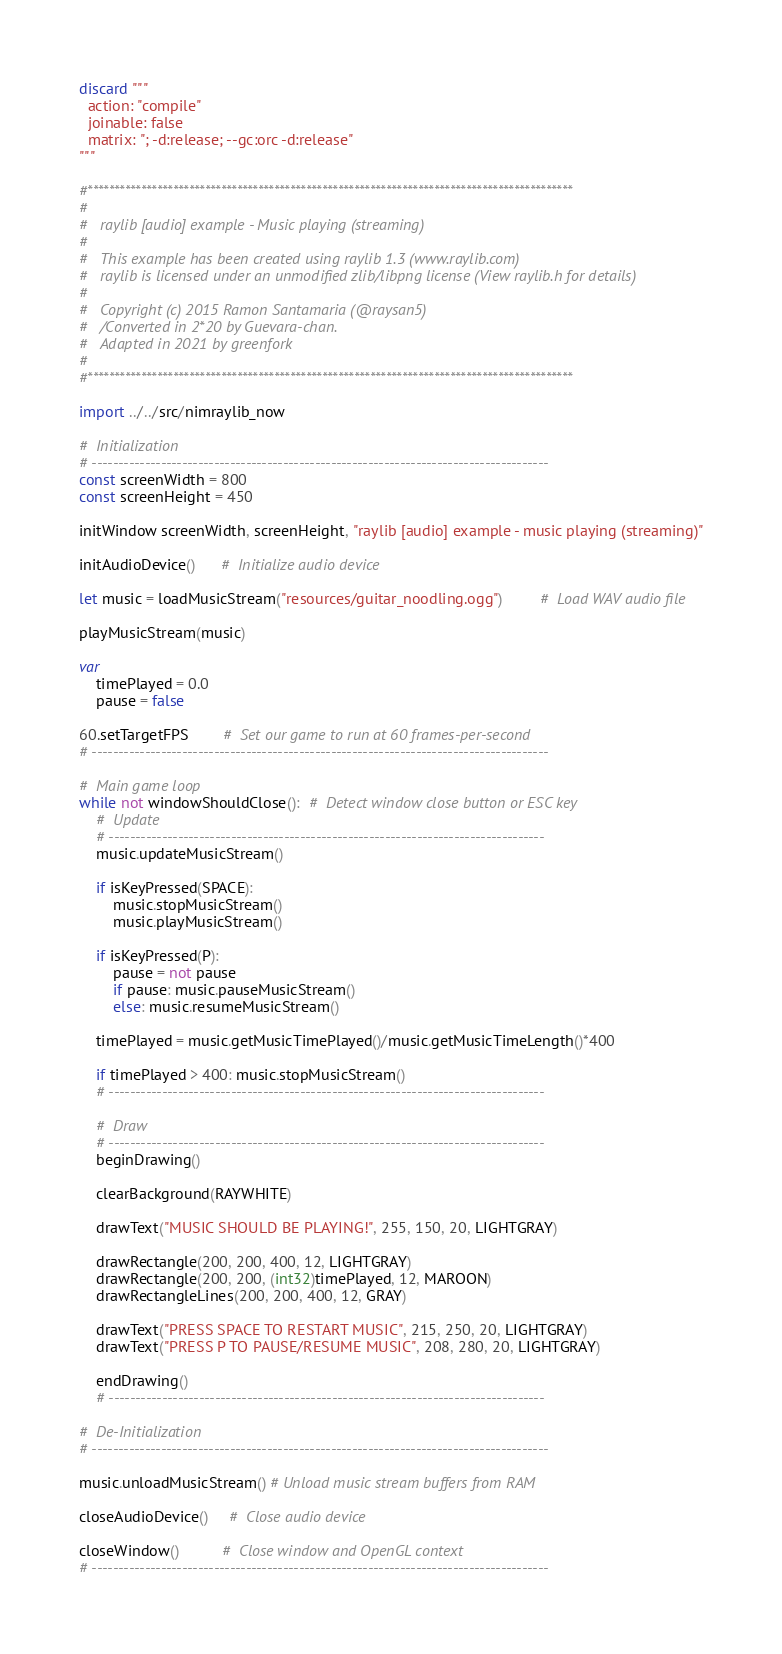<code> <loc_0><loc_0><loc_500><loc_500><_Nim_>discard """
  action: "compile"
  joinable: false
  matrix: "; -d:release; --gc:orc -d:release"
"""

#*******************************************************************************************
#
#   raylib [audio] example - Music playing (streaming)
#
#   This example has been created using raylib 1.3 (www.raylib.com)
#   raylib is licensed under an unmodified zlib/libpng license (View raylib.h for details)
#
#   Copyright (c) 2015 Ramon Santamaria (@raysan5)
#   /Converted in 2*20 by Guevara-chan.
#   Adapted in 2021 by greenfork
#
#*******************************************************************************************

import ../../src/nimraylib_now

#  Initialization
# --------------------------------------------------------------------------------------
const screenWidth = 800
const screenHeight = 450

initWindow screenWidth, screenHeight, "raylib [audio] example - music playing (streaming)"

initAudioDevice()      #  Initialize audio device

let music = loadMusicStream("resources/guitar_noodling.ogg")         #  Load WAV audio file

playMusicStream(music)

var
    timePlayed = 0.0
    pause = false

60.setTargetFPS        #  Set our game to run at 60 frames-per-second
# --------------------------------------------------------------------------------------

#  Main game loop
while not windowShouldClose():  #  Detect window close button or ESC key
    #  Update
    # ----------------------------------------------------------------------------------
    music.updateMusicStream()

    if isKeyPressed(SPACE):
        music.stopMusicStream()
        music.playMusicStream()

    if isKeyPressed(P):
        pause = not pause
        if pause: music.pauseMusicStream()
        else: music.resumeMusicStream()

    timePlayed = music.getMusicTimePlayed()/music.getMusicTimeLength()*400

    if timePlayed > 400: music.stopMusicStream()
    # ----------------------------------------------------------------------------------

    #  Draw
    # ----------------------------------------------------------------------------------
    beginDrawing()

    clearBackground(RAYWHITE)

    drawText("MUSIC SHOULD BE PLAYING!", 255, 150, 20, LIGHTGRAY)

    drawRectangle(200, 200, 400, 12, LIGHTGRAY)
    drawRectangle(200, 200, (int32)timePlayed, 12, MAROON)
    drawRectangleLines(200, 200, 400, 12, GRAY)

    drawText("PRESS SPACE TO RESTART MUSIC", 215, 250, 20, LIGHTGRAY)
    drawText("PRESS P TO PAUSE/RESUME MUSIC", 208, 280, 20, LIGHTGRAY)

    endDrawing()
    # ----------------------------------------------------------------------------------

#  De-Initialization
# --------------------------------------------------------------------------------------

music.unloadMusicStream() # Unload music stream buffers from RAM

closeAudioDevice()     #  Close audio device

closeWindow()          #  Close window and OpenGL context
# --------------------------------------------------------------------------------------
</code> 